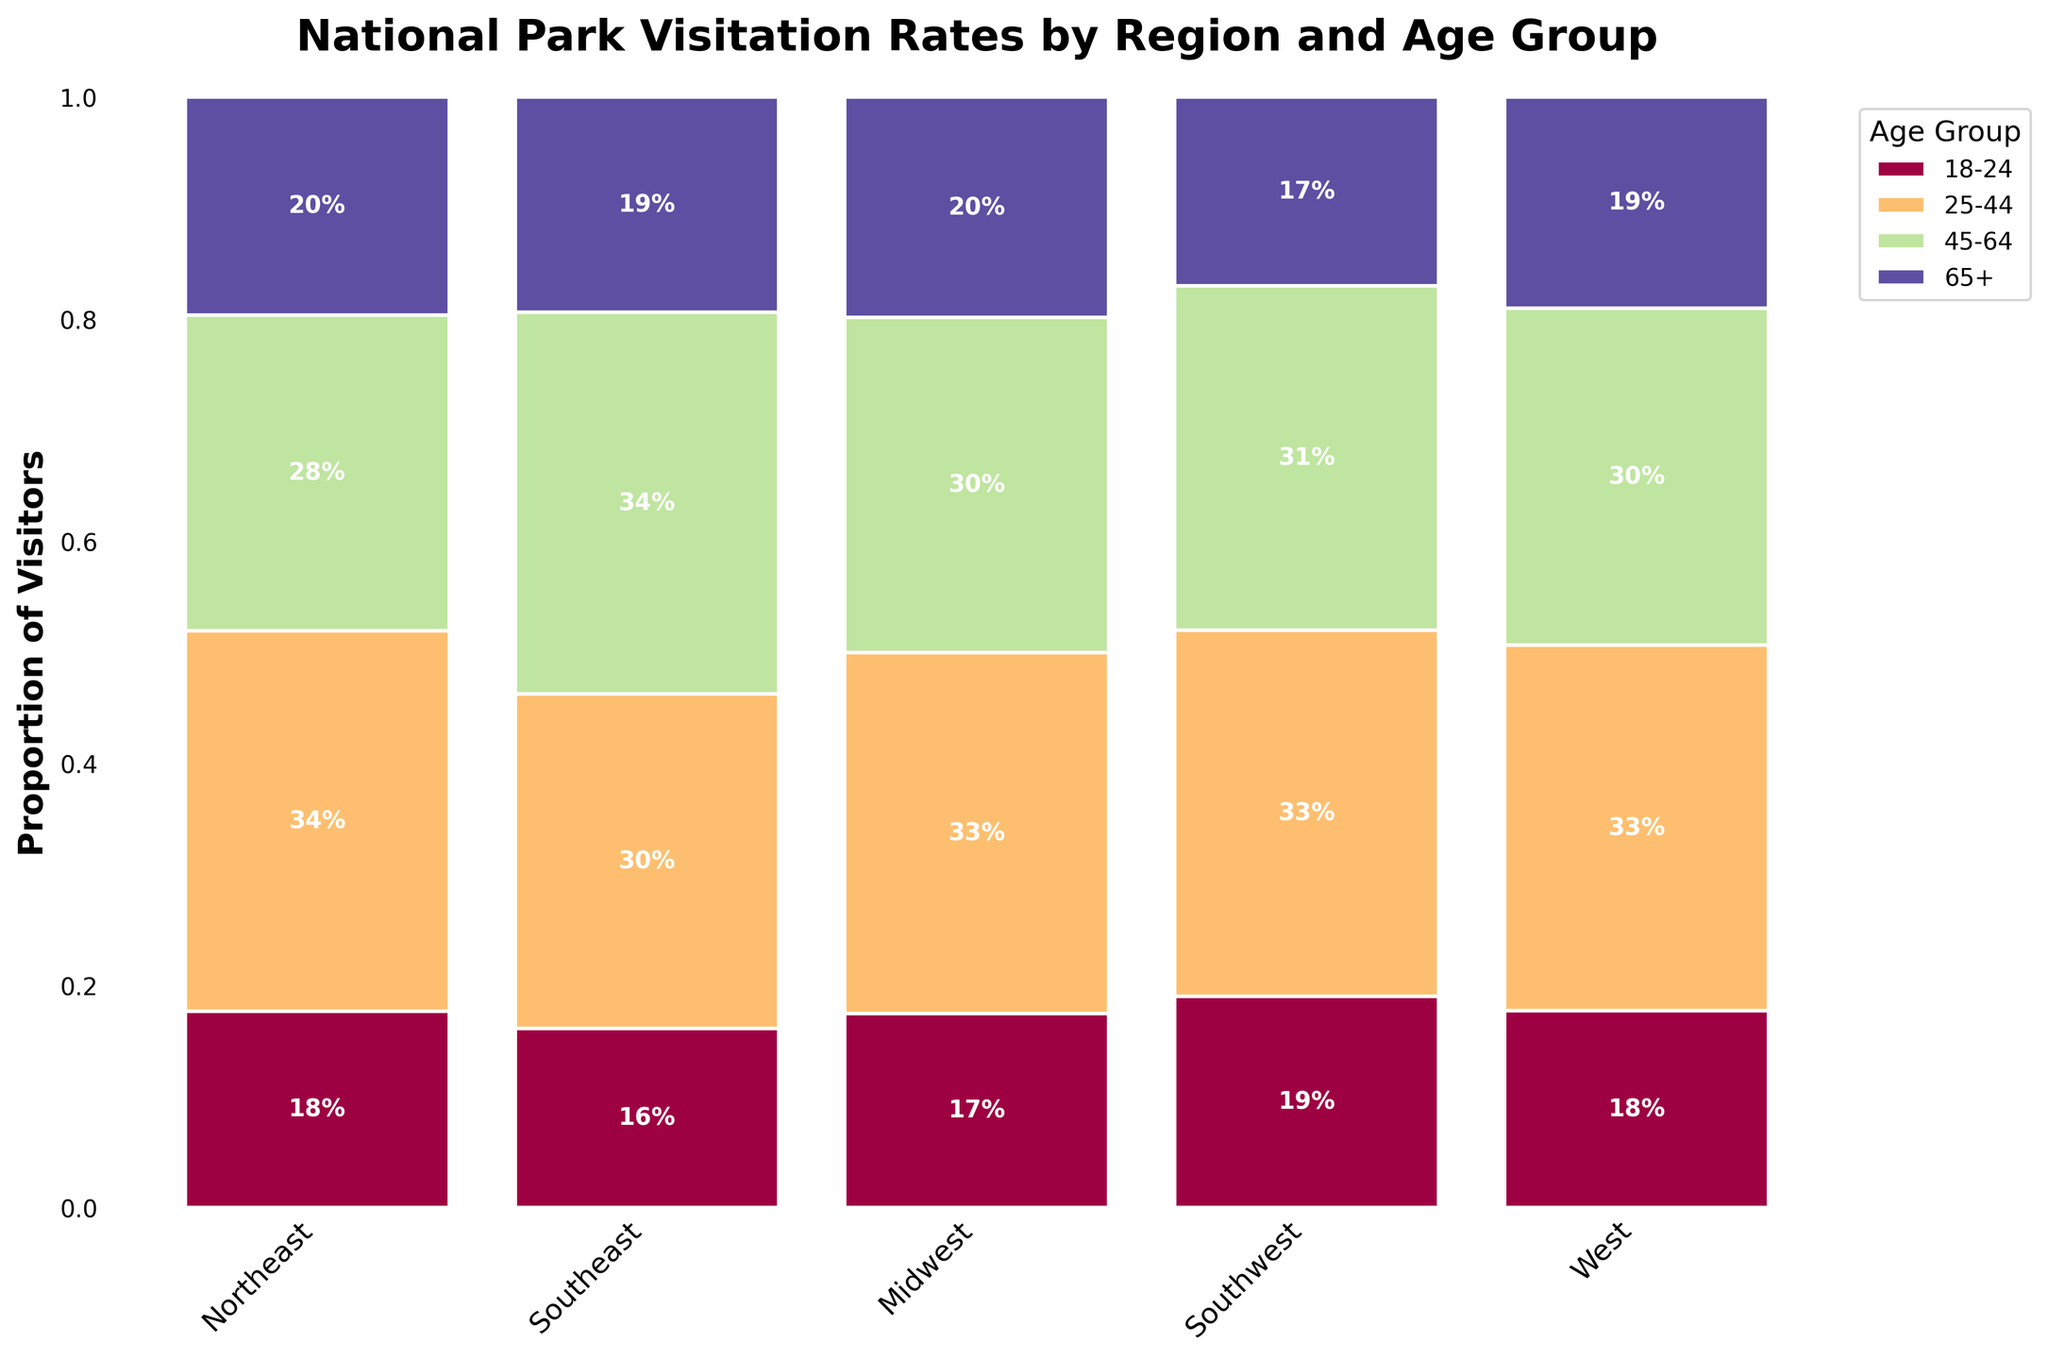What is the title of the figure? The title is displayed at the top of the figure and is usually in a larger and bold font to attract attention.
Answer: National Park Visitation Rates by Region and Age Group Which region has the highest proportion of visitors aged 18-24? The proportion of visitors aged 18-24 for each region can be identified by looking at the first colored section of the bar for each region. The bar with the largest section in this category indicates the highest proportion.
Answer: West What proportion of visitors in the Southeast are aged 45-64? To find this, locate the Southeast region's bar, and find the section labeled 45-64. The percentage is generally marked inside each section if it surpasses 10%.
Answer: 33% How does the proportion of visitors aged 65+ in the Northeast compare to the Midwest? Compare the section of the bar for visitors aged 65+ (the last colored section in each bar) between the Northeast and Midwest regions.
Answer: Northeast has a slightly lower proportion than the Midwest Which age group has the largest proportion of visitors in the West region? For the West region's bar, identify the largest section in terms of proportion. Labels and colors can help identify the age group.
Answer: 25-44 If you sum the proportions of visitors aged 25-44 and 45-64 in the Southeast, what is the result? Find the proportion of visitors aged 25-44 and 45-64 in the Southeast region by looking at the respective sections and summing them.
Answer: 73% Do the proportions of visitors aged 18-24 and 65+ in the Southwest region sum to more than 50%? Add the proportions of the 18-24 and 65+ age groups in the Southwest region by looking at their respective sections and checking if their sum exceeds 50%.
Answer: No Which region has the smallest proportion of visitors aged 65+? By examining the last section of the bars for each region, the smallest proportion can be identified.
Answer: Southwest Is the proportion of visitors aged 45-64 greater in the Midwest or the Southwest? Compare the respective sections of the bars for visitors aged 45-64 in the Midwest and Southwest regions.
Answer: Midwest 